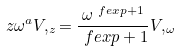Convert formula to latex. <formula><loc_0><loc_0><loc_500><loc_500>z \omega ^ { a } V , _ { z } = \frac { \omega ^ { \ f e x p + 1 } } { \ f e x p + 1 } V , _ { \omega }</formula> 